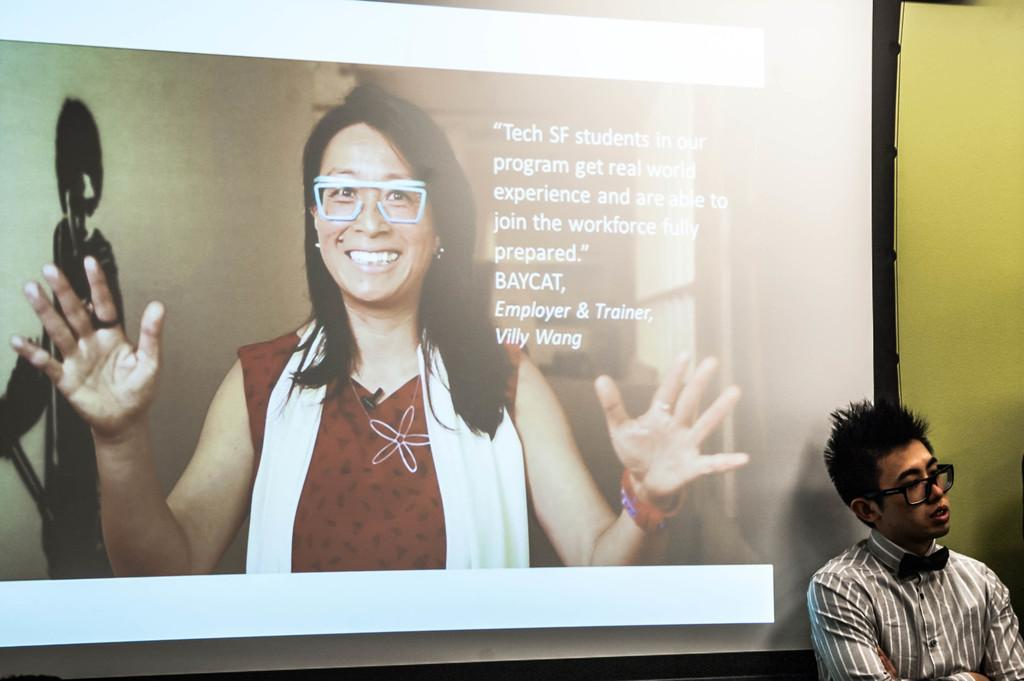Who or what can be seen in the image? There is a person present in the image. What is located behind the person? There is a screen behind the person. What is displayed on the screen? Text is visible on the screen, and there is a picture of a lady present on the screen. What else can be seen in the image? There is a wall in the image. How many goats are visible in the image? There are no goats present in the image. What type of cream is being used by the person in the image? There is no cream visible or mentioned in the image. 